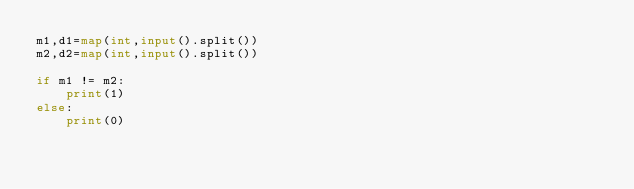<code> <loc_0><loc_0><loc_500><loc_500><_Python_>m1,d1=map(int,input().split())
m2,d2=map(int,input().split())

if m1 != m2:
    print(1)
else:
    print(0)

</code> 